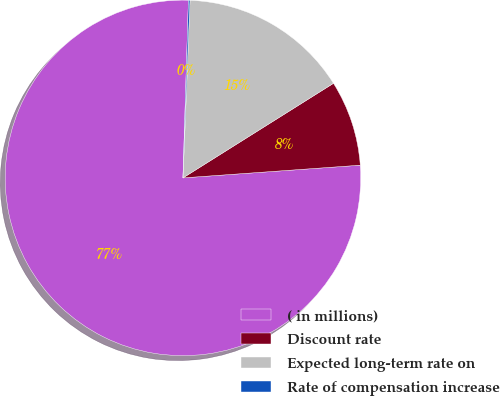<chart> <loc_0><loc_0><loc_500><loc_500><pie_chart><fcel>( in millions)<fcel>Discount rate<fcel>Expected long-term rate on<fcel>Rate of compensation increase<nl><fcel>76.63%<fcel>7.79%<fcel>15.44%<fcel>0.14%<nl></chart> 